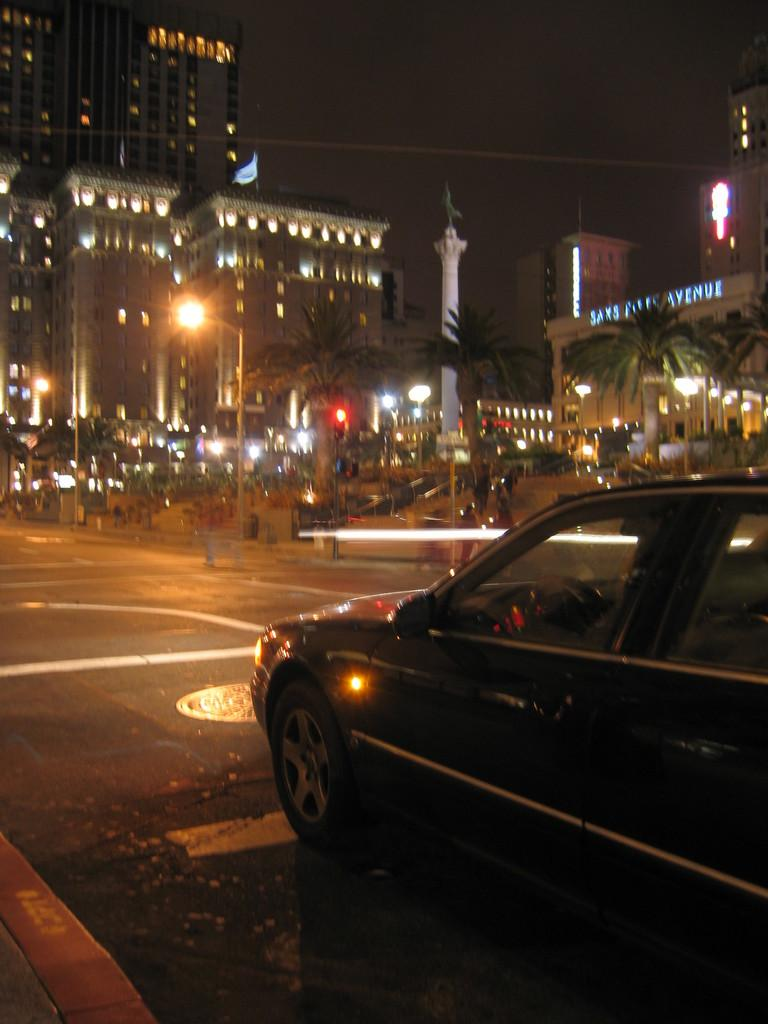What is happening on the right side of the image? There is a car moving on the road on the right side of the image. What can be seen in the middle of the image? There are big buildings in the middle of the image. What type of illumination is present in the image? Lights are present in the image. What is visible at the top of the image? The sky is visible at the top of the image. What time of day is the image set in? The image is set during nighttime. What type of guitar can be seen being played by the hen in the image? There is no guitar or hen present in the image. What type of truck is visible in the image? There is no truck visible in the image. 